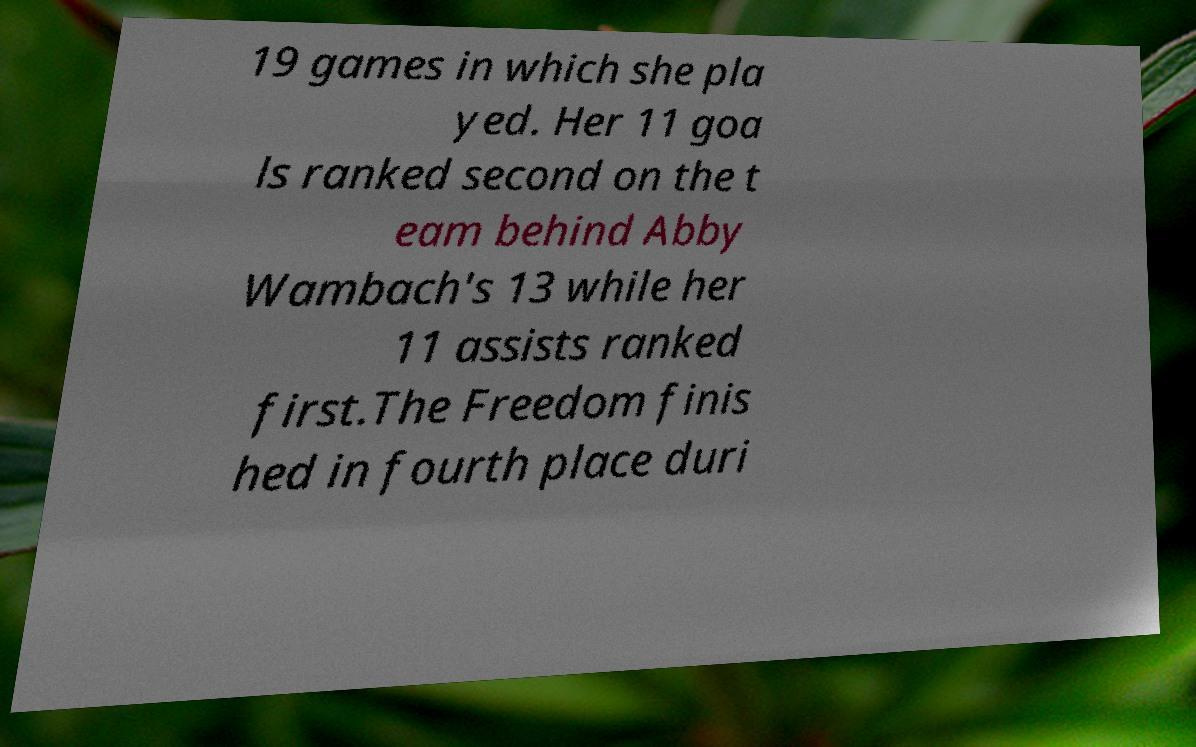Can you accurately transcribe the text from the provided image for me? 19 games in which she pla yed. Her 11 goa ls ranked second on the t eam behind Abby Wambach's 13 while her 11 assists ranked first.The Freedom finis hed in fourth place duri 